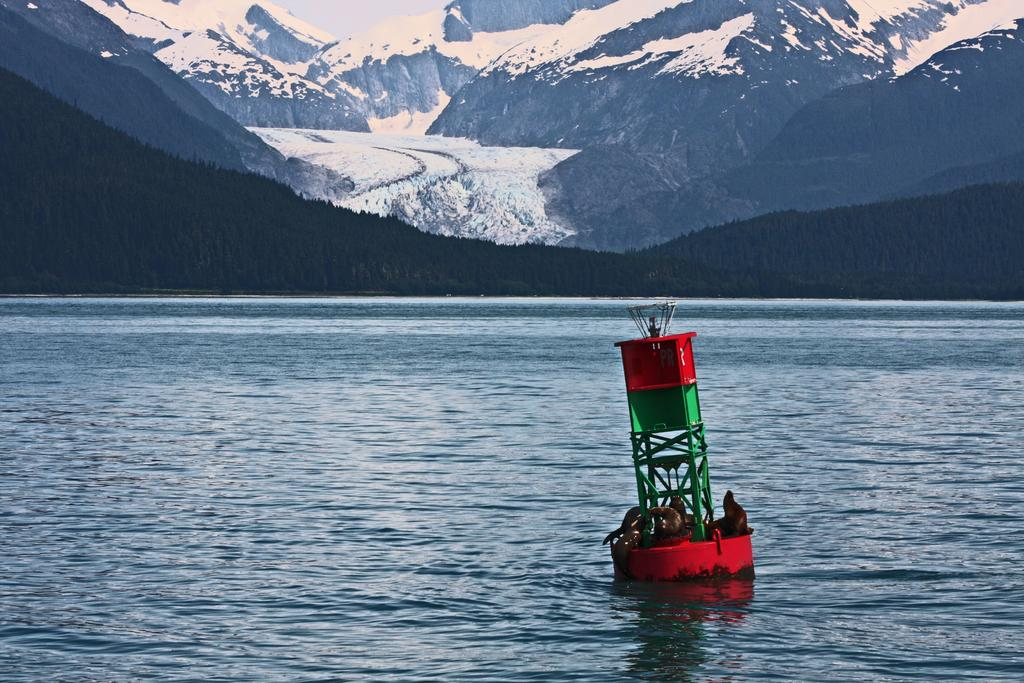What is the main subject of the image? There is an object on the water. What can be seen on the object? There are animals on the object. What type of natural scenery is visible in the background of the image? There are trees and hills in the background of the image. What type of food is being served at the religious ceremony in the image? There is no religious ceremony or food present in the image. The image features an object on the water with animals on it, and trees and hills in the background. 